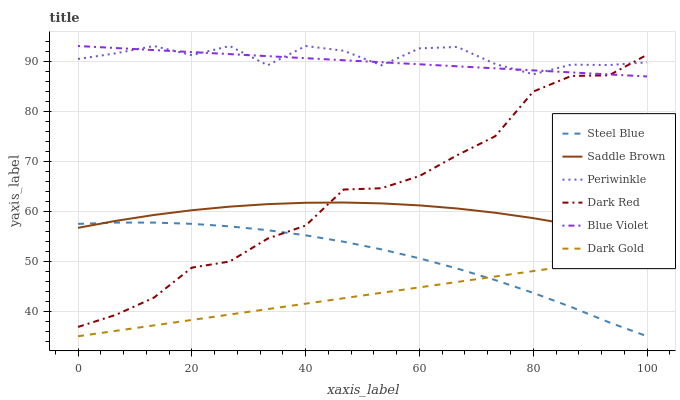Does Dark Gold have the minimum area under the curve?
Answer yes or no. Yes. Does Periwinkle have the maximum area under the curve?
Answer yes or no. Yes. Does Dark Red have the minimum area under the curve?
Answer yes or no. No. Does Dark Red have the maximum area under the curve?
Answer yes or no. No. Is Dark Gold the smoothest?
Answer yes or no. Yes. Is Periwinkle the roughest?
Answer yes or no. Yes. Is Dark Red the smoothest?
Answer yes or no. No. Is Dark Red the roughest?
Answer yes or no. No. Does Dark Gold have the lowest value?
Answer yes or no. Yes. Does Dark Red have the lowest value?
Answer yes or no. No. Does Blue Violet have the highest value?
Answer yes or no. Yes. Does Dark Red have the highest value?
Answer yes or no. No. Is Steel Blue less than Blue Violet?
Answer yes or no. Yes. Is Saddle Brown greater than Dark Gold?
Answer yes or no. Yes. Does Dark Gold intersect Steel Blue?
Answer yes or no. Yes. Is Dark Gold less than Steel Blue?
Answer yes or no. No. Is Dark Gold greater than Steel Blue?
Answer yes or no. No. Does Steel Blue intersect Blue Violet?
Answer yes or no. No. 